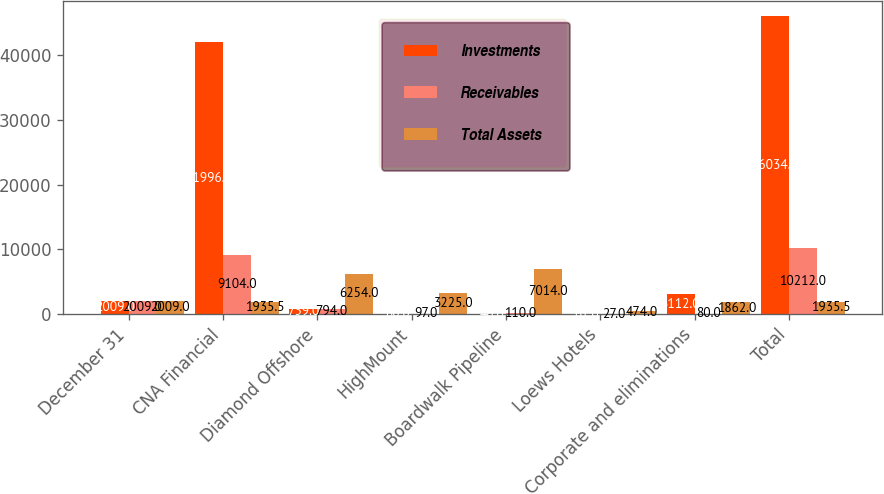Convert chart to OTSL. <chart><loc_0><loc_0><loc_500><loc_500><stacked_bar_chart><ecel><fcel>December 31<fcel>CNA Financial<fcel>Diamond Offshore<fcel>HighMount<fcel>Boardwalk Pipeline<fcel>Loews Hotels<fcel>Corporate and eliminations<fcel>Total<nl><fcel>Investments<fcel>2009<fcel>41996<fcel>739<fcel>80<fcel>46<fcel>61<fcel>3112<fcel>46034<nl><fcel>Receivables<fcel>2009<fcel>9104<fcel>794<fcel>97<fcel>110<fcel>27<fcel>80<fcel>10212<nl><fcel>Total Assets<fcel>2009<fcel>1935.5<fcel>6254<fcel>3225<fcel>7014<fcel>474<fcel>1862<fcel>1935.5<nl></chart> 